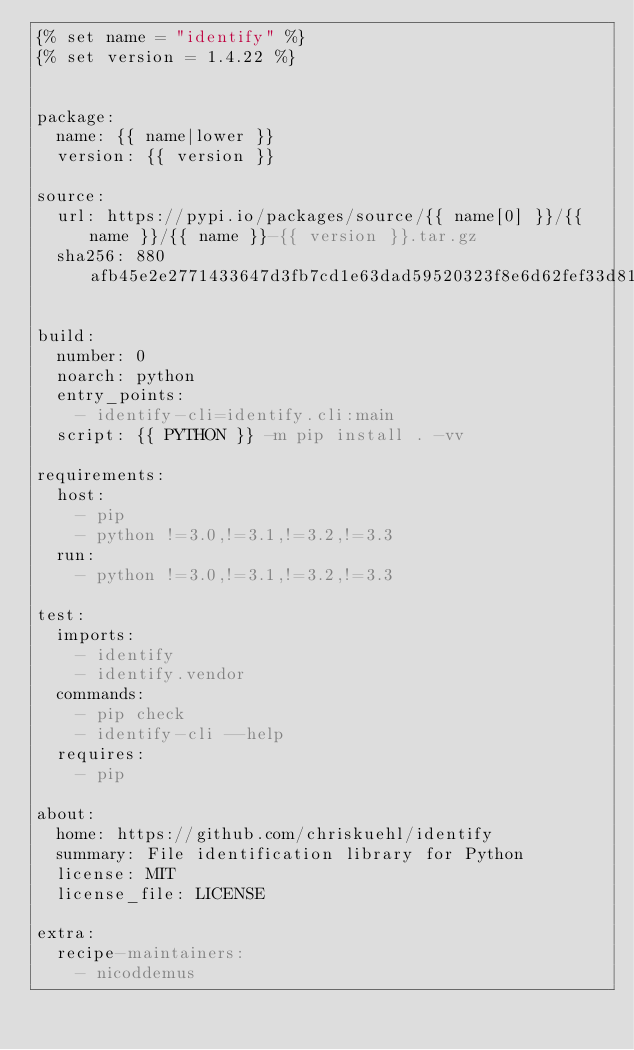<code> <loc_0><loc_0><loc_500><loc_500><_YAML_>{% set name = "identify" %}
{% set version = 1.4.22 %}


package:
  name: {{ name|lower }}
  version: {{ version }}

source:
  url: https://pypi.io/packages/source/{{ name[0] }}/{{ name }}/{{ name }}-{{ version }}.tar.gz
  sha256: 880afb45e2e2771433647d3fb7cd1e63dad59520323f8e6d62fef33d811fa3ad

build:
  number: 0
  noarch: python
  entry_points:
    - identify-cli=identify.cli:main
  script: {{ PYTHON }} -m pip install . -vv

requirements:
  host:
    - pip
    - python !=3.0,!=3.1,!=3.2,!=3.3
  run:
    - python !=3.0,!=3.1,!=3.2,!=3.3

test:
  imports:
    - identify
    - identify.vendor
  commands:
    - pip check
    - identify-cli --help
  requires:
    - pip

about:
  home: https://github.com/chriskuehl/identify
  summary: File identification library for Python
  license: MIT
  license_file: LICENSE

extra:
  recipe-maintainers:
    - nicoddemus
</code> 